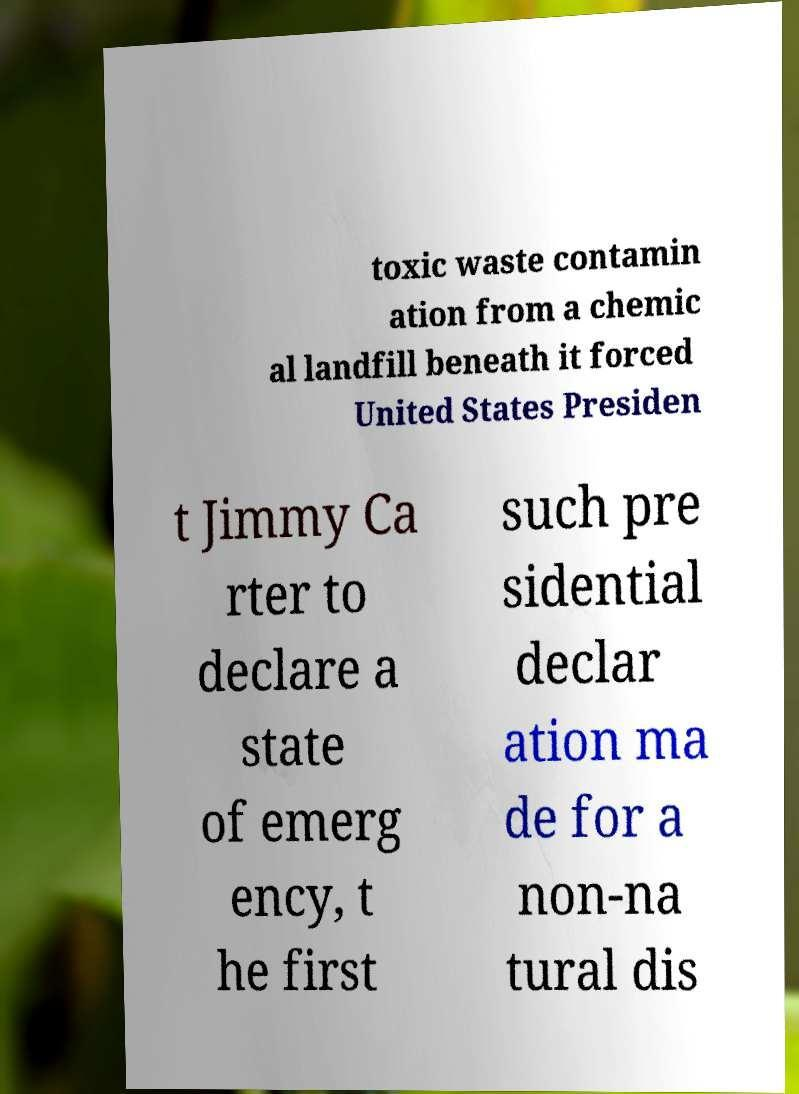Can you read and provide the text displayed in the image?This photo seems to have some interesting text. Can you extract and type it out for me? toxic waste contamin ation from a chemic al landfill beneath it forced United States Presiden t Jimmy Ca rter to declare a state of emerg ency, t he first such pre sidential declar ation ma de for a non-na tural dis 